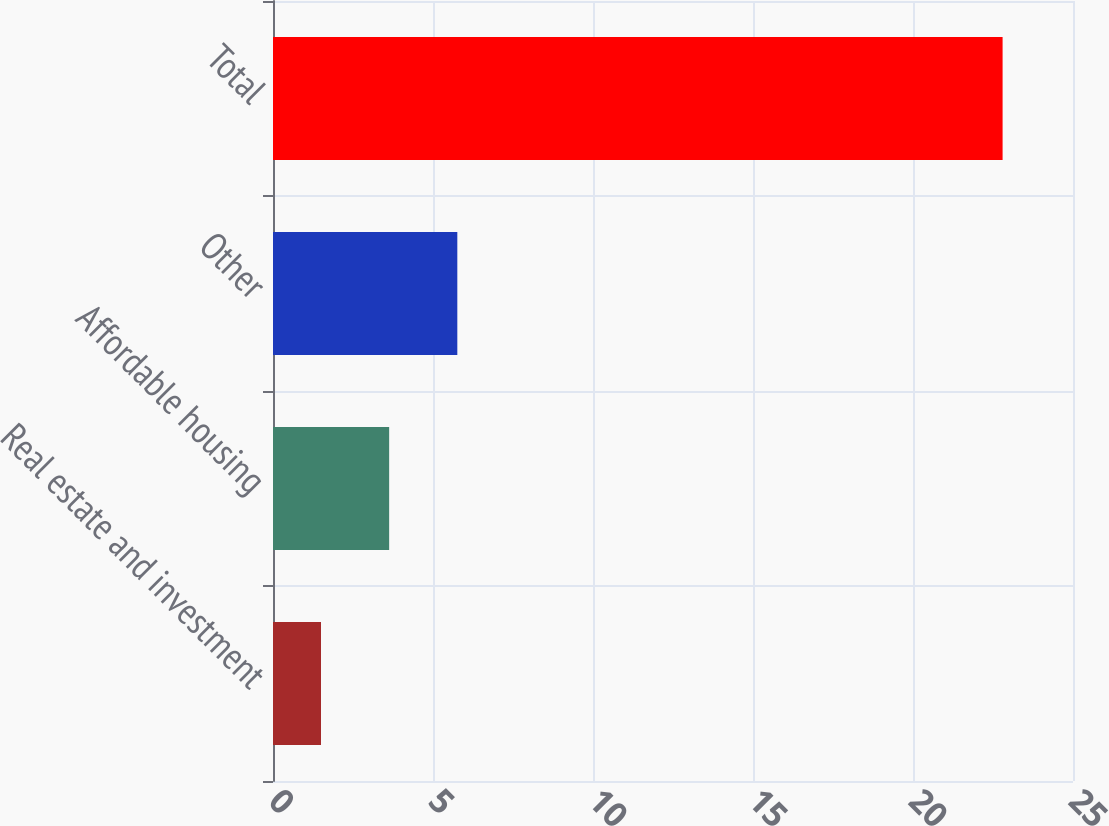Convert chart to OTSL. <chart><loc_0><loc_0><loc_500><loc_500><bar_chart><fcel>Real estate and investment<fcel>Affordable housing<fcel>Other<fcel>Total<nl><fcel>1.5<fcel>3.63<fcel>5.76<fcel>22.8<nl></chart> 